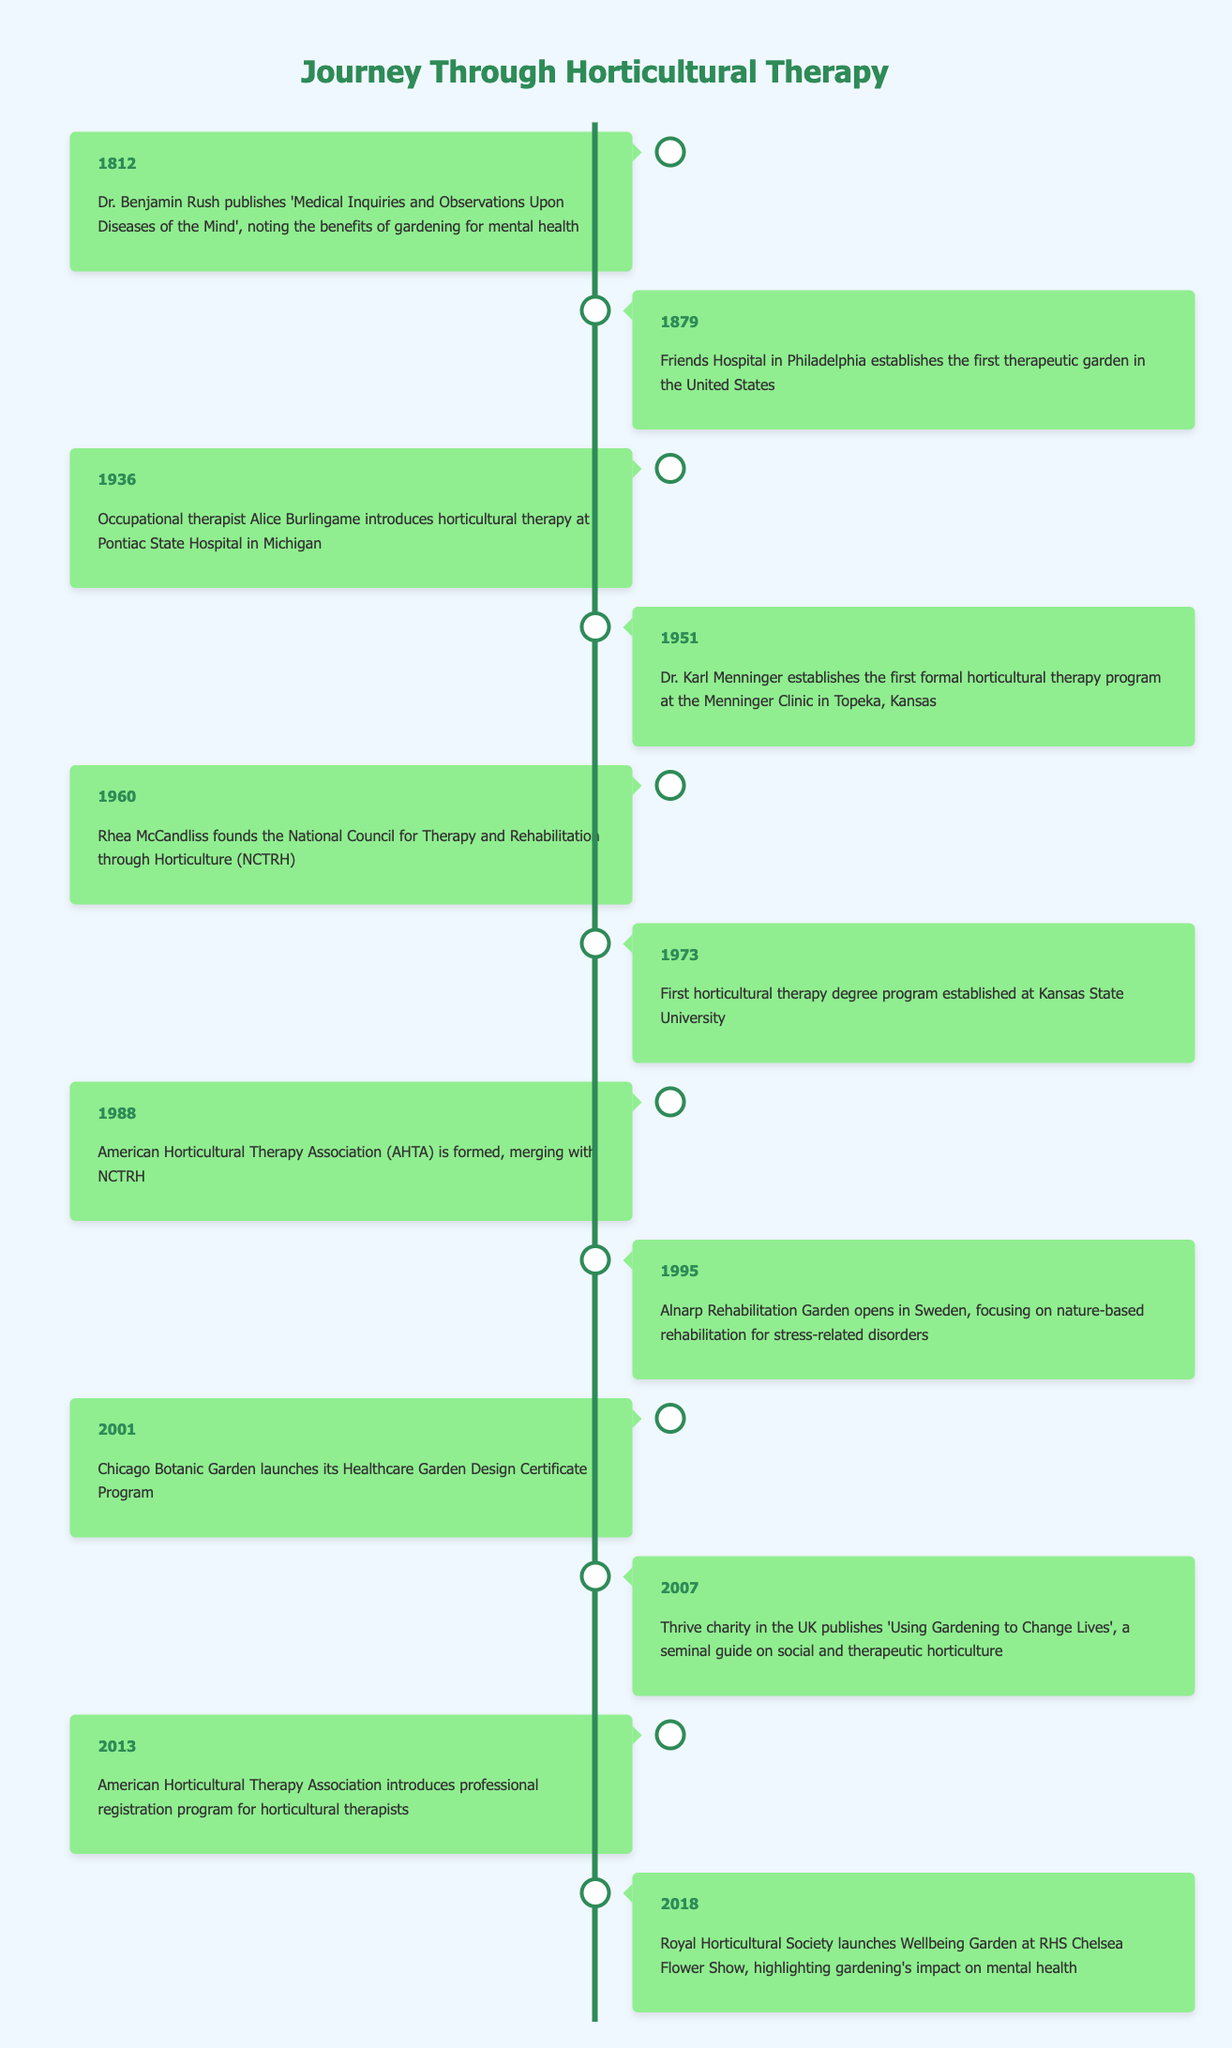What year did Dr. Benjamin Rush publish his work on gardening and mental health? According to the table, Dr. Benjamin Rush published 'Medical Inquiries and Observations Upon Diseases of the Mind' in 1812, highlighting the benefits of gardening for mental health.
Answer: 1812 Which event marks the establishment of the first therapeutic garden in the United States? The table indicates that in 1879, Friends Hospital in Philadelphia established the first therapeutic garden in the United States.
Answer: Friends Hospital in 1879 How many years passed between the introduction of horticultural therapy by Alice Burlingame and the establishment of the first formal horticultural therapy program? Alice Burlingame introduced horticultural therapy in 1936 and the first formal program was established in 1951. The difference is 1951 - 1936 = 15 years.
Answer: 15 years Did the American Horticultural Therapy Association form before or after the establishment of the first horticultural therapy degree program? The table shows that the American Horticultural Therapy Association was formed in 1988, while the first degree program was established in 1973. Thus, AHTA formed after the degree program's establishment.
Answer: After What is the range of years during which the events in the table occurred? The first event listed is from 1812 and the last event is from 2018. Therefore, the range of years is 2018 - 1812 = 206 years.
Answer: 206 years How many significant events related to horticultural therapy occurred in the 2000s? The table lists three events in the 2000s: the launch of the Healthcare Garden Design Certificate Program in 2001, the publishing of 'Using Gardening to Change Lives' in 2007, and the introduction of the professional registration program in 2013. Thus, there are three events overall in that decade.
Answer: 3 events Is it true that the Royal Horticultural Society launched the Wellbeing Garden before the introduction of the professional registration program? The table states that the professional registration program was introduced in 2013, and the Wellbeing Garden was launched in 2018, confirming that it is true that the Wellbeing Garden was launched after the program.
Answer: Yes How does the number of events in the 19th century compare to the number of events in the 21st century? Looking at the table, there are three events in the 19th century (1812, 1879, 1936) and five events in the 21st century (2001, 2007, 2013, 2018). So, there are more events in the 21st century.
Answer: More in the 21st century 